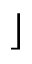<formula> <loc_0><loc_0><loc_500><loc_500>\rfloor</formula> 